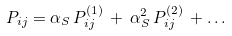<formula> <loc_0><loc_0><loc_500><loc_500>P _ { i j } = \alpha _ { S } \, P _ { i j } ^ { ( 1 ) } \, + \, \alpha _ { S } ^ { 2 } \, P _ { i j } ^ { ( 2 ) } \, + \dots</formula> 